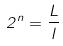<formula> <loc_0><loc_0><loc_500><loc_500>2 ^ { n } = \frac { L } { l }</formula> 